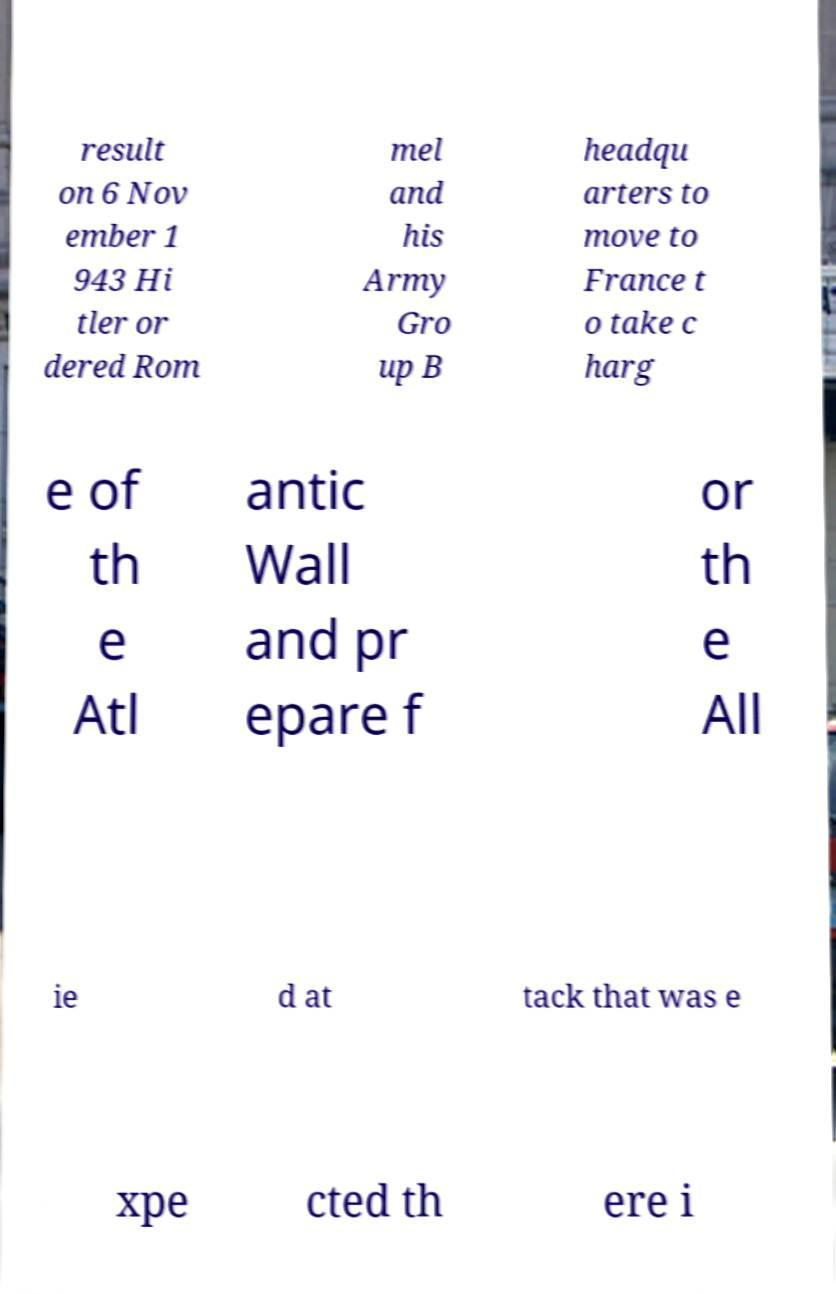What messages or text are displayed in this image? I need them in a readable, typed format. result on 6 Nov ember 1 943 Hi tler or dered Rom mel and his Army Gro up B headqu arters to move to France t o take c harg e of th e Atl antic Wall and pr epare f or th e All ie d at tack that was e xpe cted th ere i 